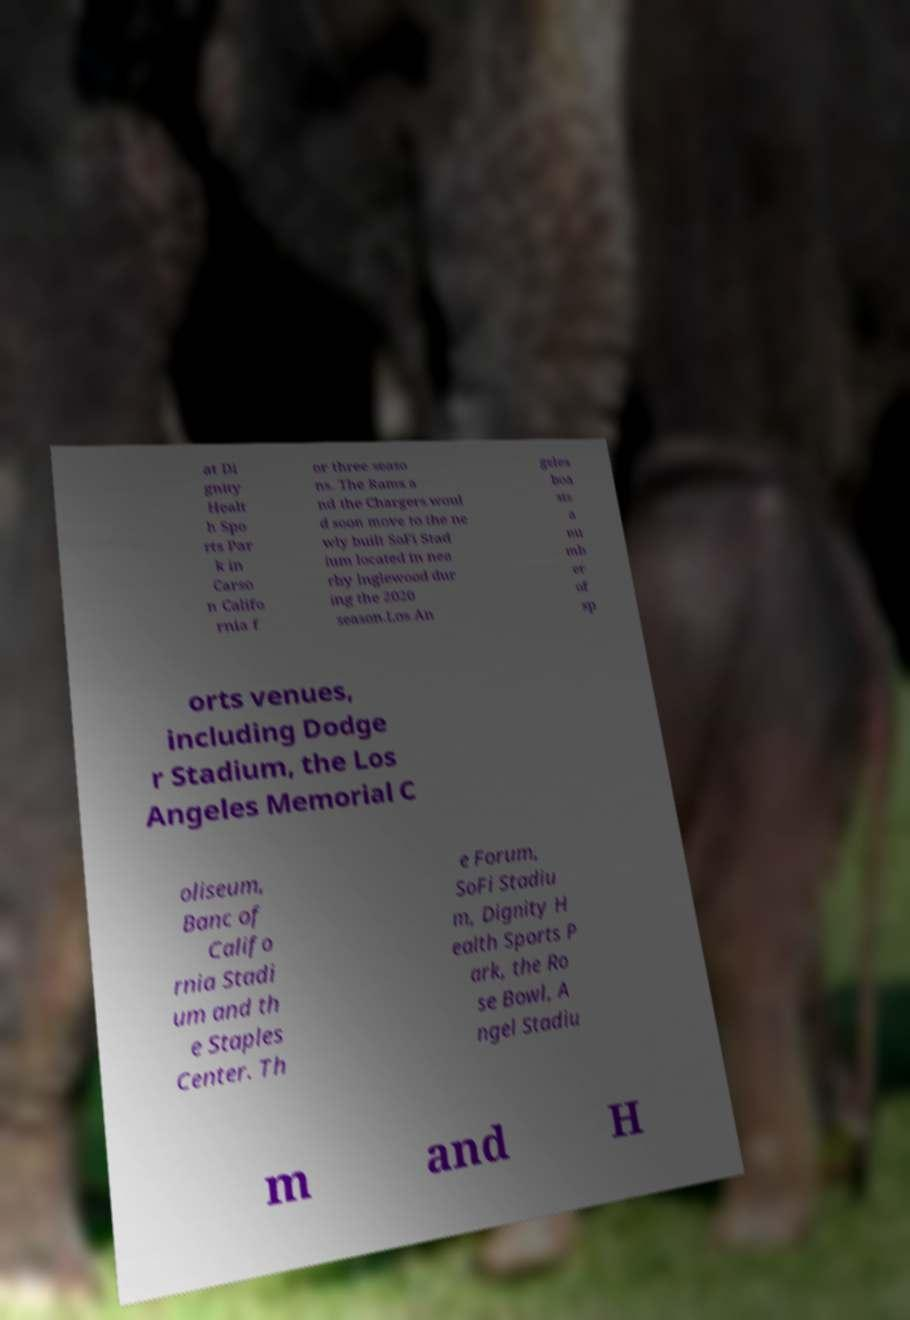Could you assist in decoding the text presented in this image and type it out clearly? at Di gnity Healt h Spo rts Par k in Carso n Califo rnia f or three seaso ns. The Rams a nd the Chargers woul d soon move to the ne wly built SoFi Stad ium located in nea rby Inglewood dur ing the 2020 season.Los An geles boa sts a nu mb er of sp orts venues, including Dodge r Stadium, the Los Angeles Memorial C oliseum, Banc of Califo rnia Stadi um and th e Staples Center. Th e Forum, SoFi Stadiu m, Dignity H ealth Sports P ark, the Ro se Bowl, A ngel Stadiu m and H 